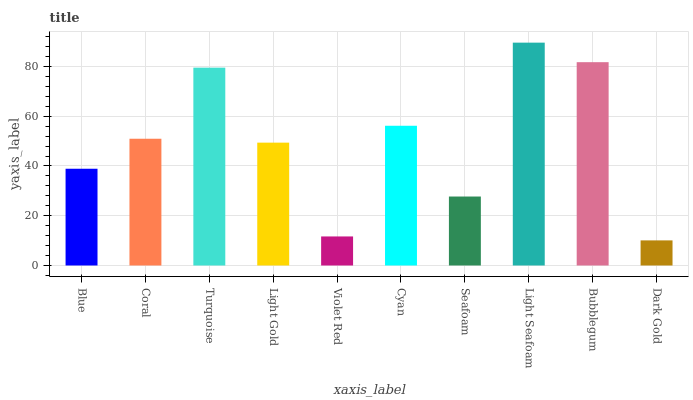Is Dark Gold the minimum?
Answer yes or no. Yes. Is Light Seafoam the maximum?
Answer yes or no. Yes. Is Coral the minimum?
Answer yes or no. No. Is Coral the maximum?
Answer yes or no. No. Is Coral greater than Blue?
Answer yes or no. Yes. Is Blue less than Coral?
Answer yes or no. Yes. Is Blue greater than Coral?
Answer yes or no. No. Is Coral less than Blue?
Answer yes or no. No. Is Coral the high median?
Answer yes or no. Yes. Is Light Gold the low median?
Answer yes or no. Yes. Is Light Seafoam the high median?
Answer yes or no. No. Is Cyan the low median?
Answer yes or no. No. 